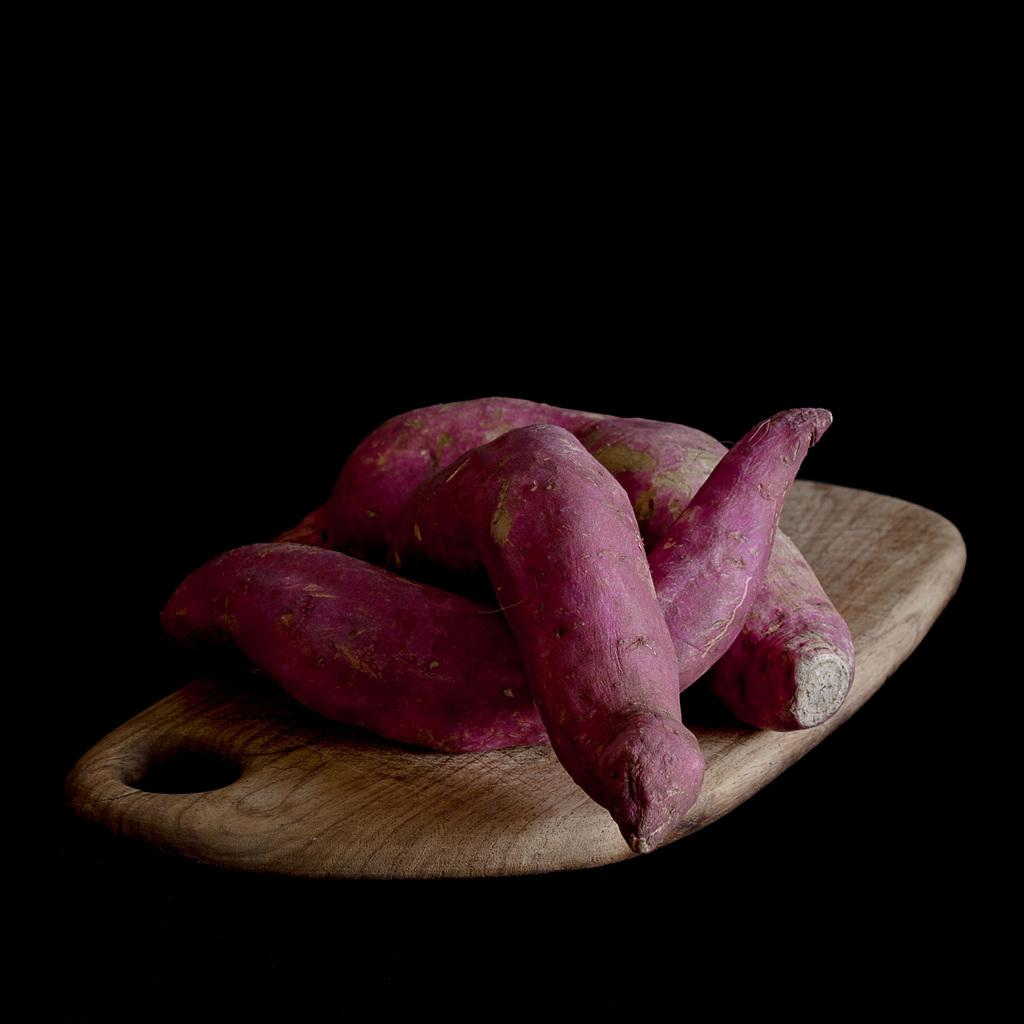What type of food is visible in the image? There are sweet potatoes in the image. Where are the sweet potatoes placed? The sweet potatoes are on a wooden board. What statement does the judge make about the night in the image? There is no judge or statement about the night in the image, as it only features sweet potatoes on a wooden board. 